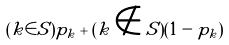Convert formula to latex. <formula><loc_0><loc_0><loc_500><loc_500>( k \in S ) p _ { k } + ( k \notin S ) ( 1 - p _ { k } )</formula> 